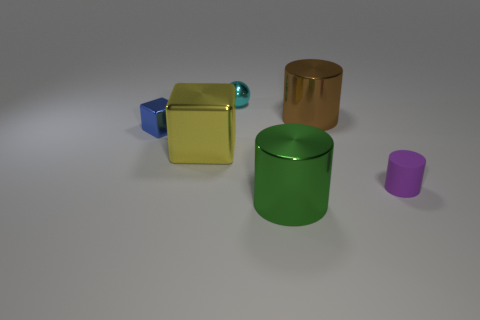Is the number of blue metal blocks less than the number of tiny gray blocks?
Offer a very short reply. No. What is the size of the metallic object that is both on the left side of the green shiny object and behind the tiny blue object?
Give a very brief answer. Small. What is the size of the shiny cylinder behind the large shiny cylinder that is in front of the shiny block that is left of the large metallic block?
Provide a short and direct response. Large. What size is the cyan metal thing?
Give a very brief answer. Small. Is there any other thing that has the same material as the big cube?
Make the answer very short. Yes. Is there a big green object behind the small object in front of the tiny metallic object left of the cyan thing?
Keep it short and to the point. No. What number of big objects are cyan shiny balls or cyan shiny cylinders?
Make the answer very short. 0. Are there any other things that are the same color as the rubber object?
Your answer should be compact. No. There is a object that is on the left side of the yellow metallic object; is its size the same as the tiny cyan metal object?
Offer a very short reply. Yes. What is the color of the small object that is behind the large metal cylinder that is behind the large metal object that is left of the cyan metal ball?
Give a very brief answer. Cyan. 